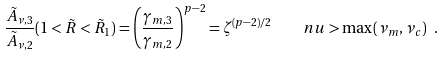Convert formula to latex. <formula><loc_0><loc_0><loc_500><loc_500>\frac { \tilde { A } _ { \nu , 3 } } { \tilde { A } _ { \nu , 2 } } ( 1 < \tilde { R } < \tilde { R } _ { 1 } ) = \left ( \frac { \gamma _ { m , 3 } } { \gamma _ { m , 2 } } \right ) ^ { p - 2 } = \zeta ^ { ( p - 2 ) / 2 } \quad n u > \max ( \nu _ { m } , \nu _ { c } ) \ .</formula> 